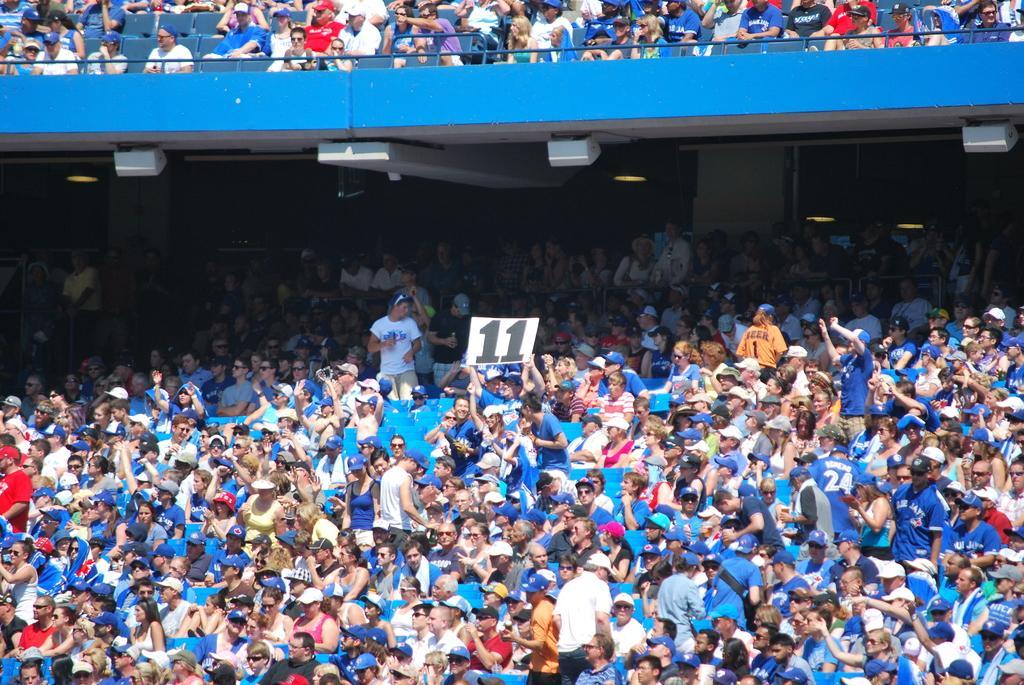Can you describe this image briefly? In this image we can see many people sitting on chairs. And this is a stadium. Also we can see some people wearing caps. And there is a person holding a paper with a number. 